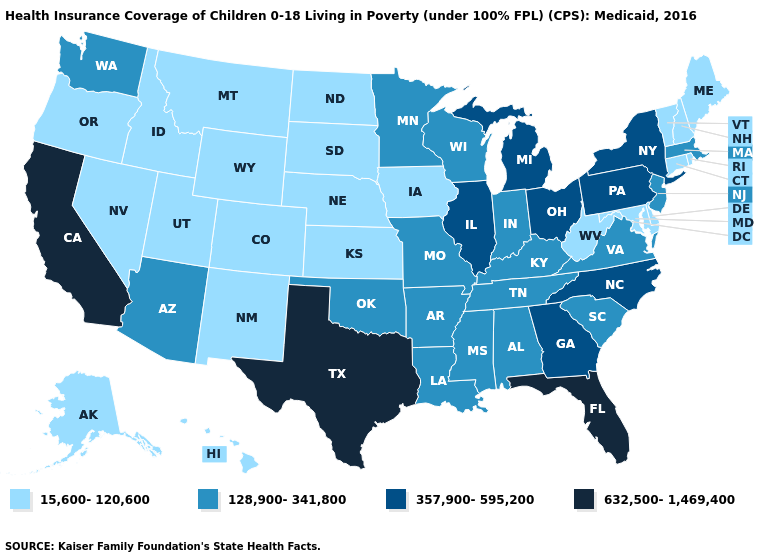Does Michigan have a higher value than North Dakota?
Quick response, please. Yes. Does Minnesota have the lowest value in the USA?
Concise answer only. No. Does California have the highest value in the West?
Quick response, please. Yes. Does Mississippi have the same value as Nebraska?
Be succinct. No. What is the highest value in the USA?
Short answer required. 632,500-1,469,400. How many symbols are there in the legend?
Give a very brief answer. 4. Does Arizona have a higher value than Iowa?
Quick response, please. Yes. Does Texas have the highest value in the USA?
Be succinct. Yes. What is the highest value in states that border South Carolina?
Answer briefly. 357,900-595,200. What is the value of Utah?
Write a very short answer. 15,600-120,600. Name the states that have a value in the range 15,600-120,600?
Concise answer only. Alaska, Colorado, Connecticut, Delaware, Hawaii, Idaho, Iowa, Kansas, Maine, Maryland, Montana, Nebraska, Nevada, New Hampshire, New Mexico, North Dakota, Oregon, Rhode Island, South Dakota, Utah, Vermont, West Virginia, Wyoming. Name the states that have a value in the range 128,900-341,800?
Be succinct. Alabama, Arizona, Arkansas, Indiana, Kentucky, Louisiana, Massachusetts, Minnesota, Mississippi, Missouri, New Jersey, Oklahoma, South Carolina, Tennessee, Virginia, Washington, Wisconsin. What is the value of Wisconsin?
Write a very short answer. 128,900-341,800. What is the value of Kentucky?
Short answer required. 128,900-341,800. What is the value of Oregon?
Be succinct. 15,600-120,600. 